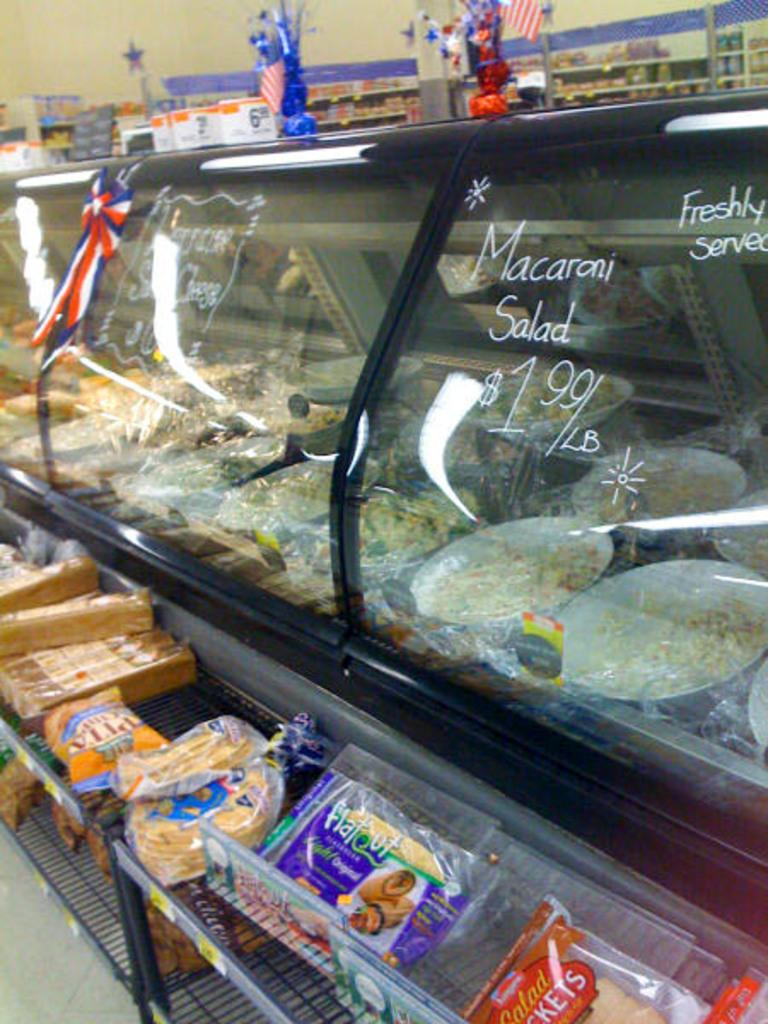<image>
Create a compact narrative representing the image presented. Food on display under glass with "Macaroni Salad" on the glass. 